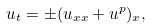Convert formula to latex. <formula><loc_0><loc_0><loc_500><loc_500>u _ { t } = \pm ( u _ { x x } + u ^ { p } ) _ { x } ,</formula> 